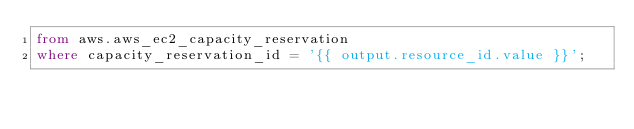Convert code to text. <code><loc_0><loc_0><loc_500><loc_500><_SQL_>from aws.aws_ec2_capacity_reservation
where capacity_reservation_id = '{{ output.resource_id.value }}';
</code> 